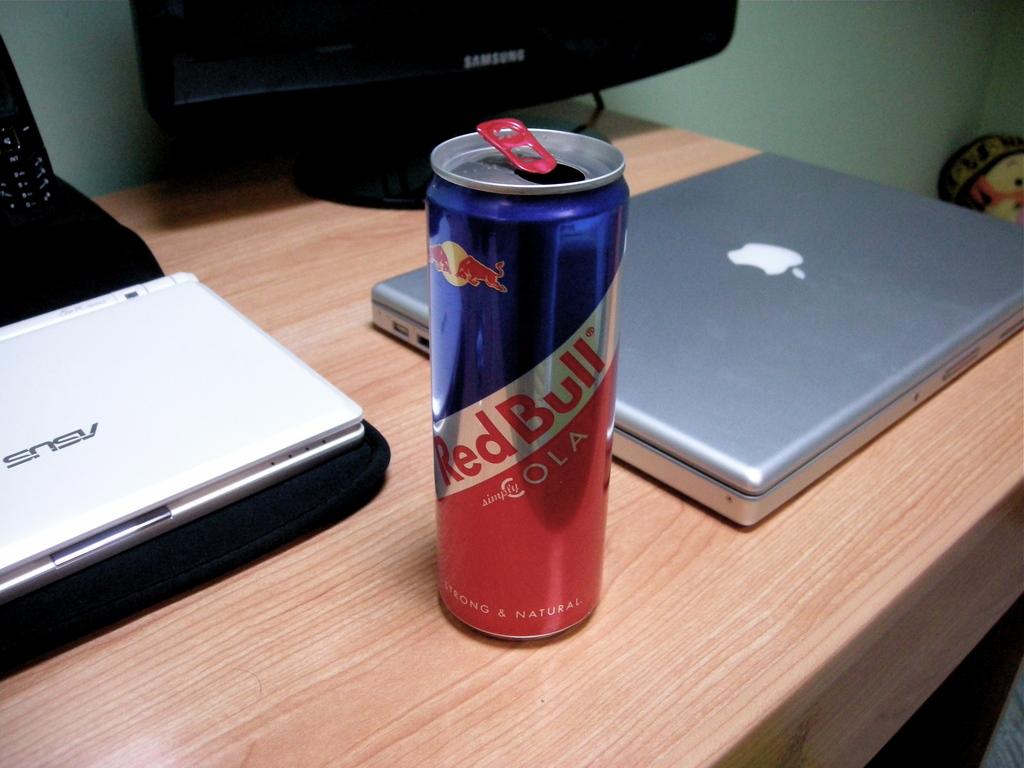What laptop brand is the computer on the left?
Make the answer very short. Asus. 